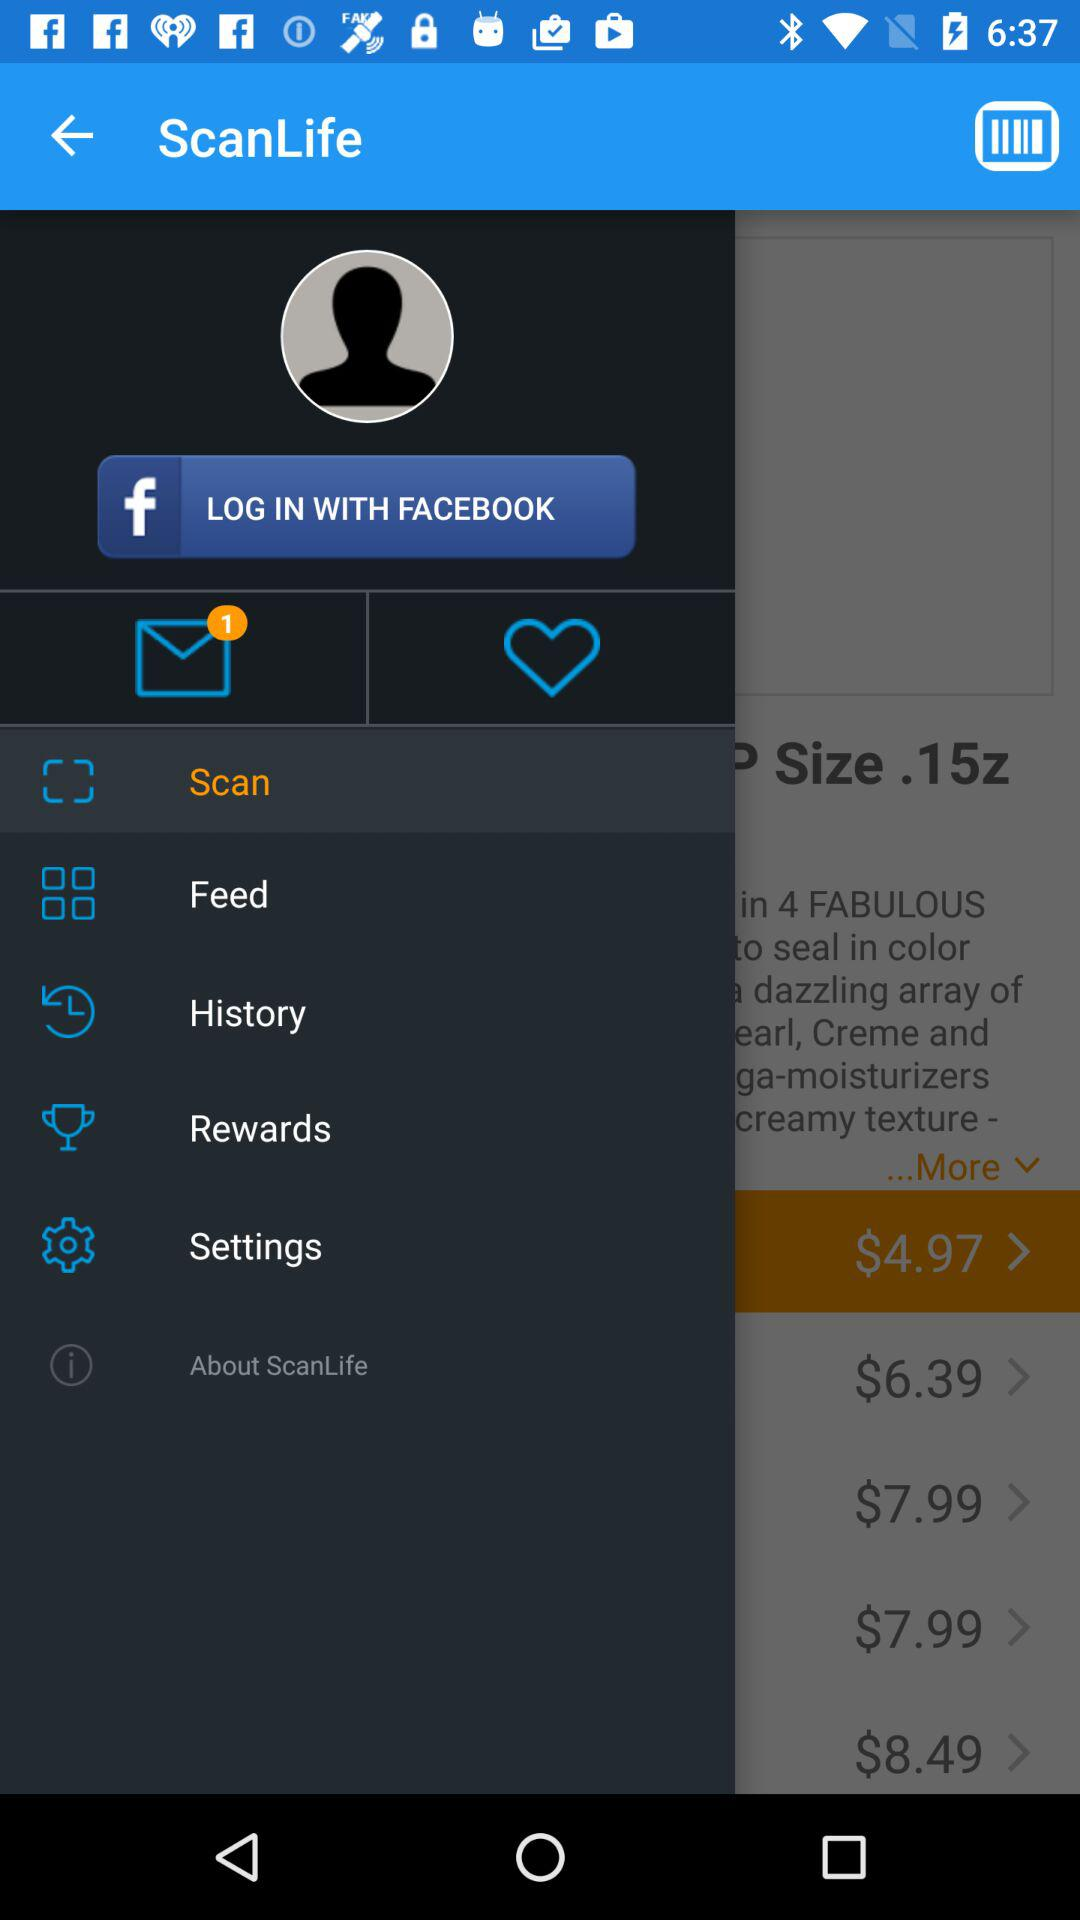What is the application name?
When the provided information is insufficient, respond with <no answer>. <no answer> 